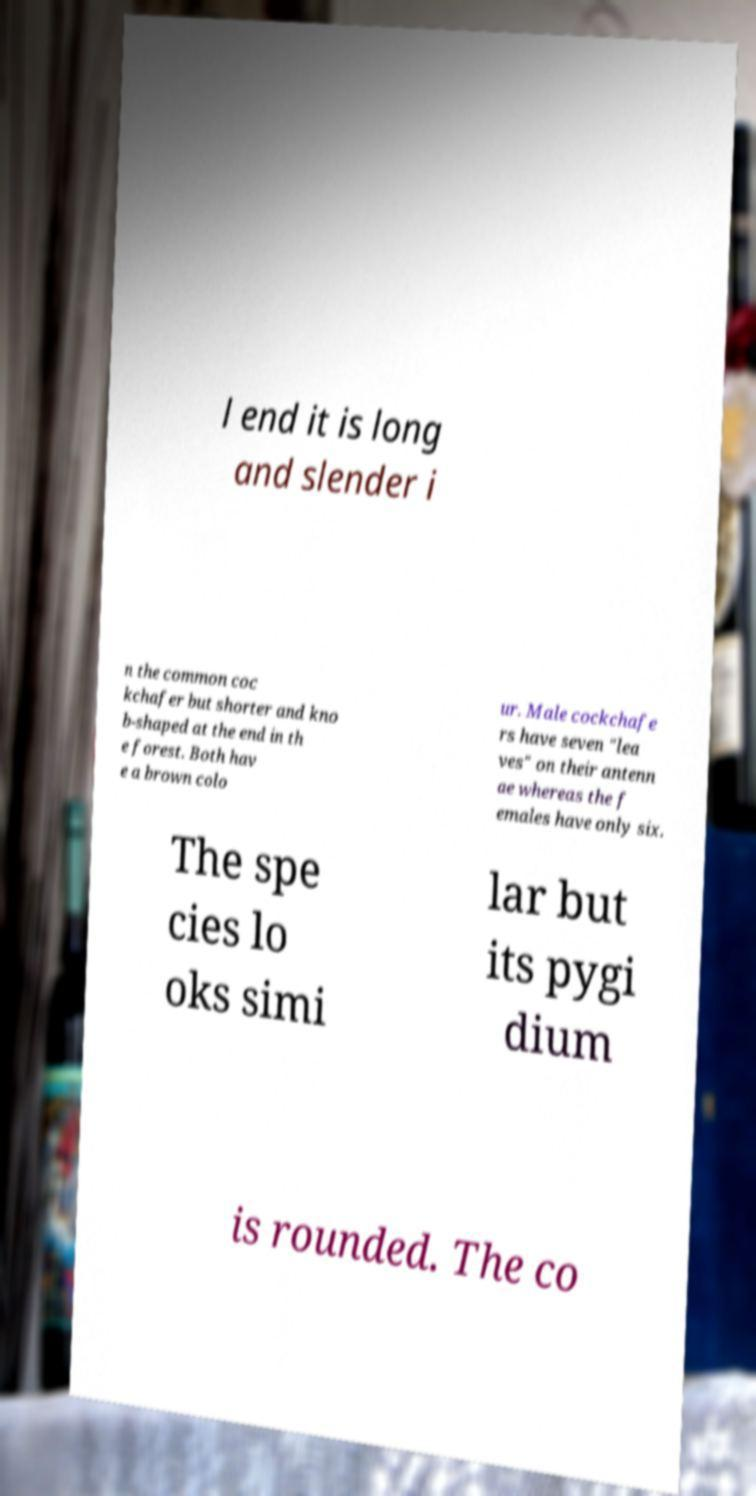What messages or text are displayed in this image? I need them in a readable, typed format. l end it is long and slender i n the common coc kchafer but shorter and kno b-shaped at the end in th e forest. Both hav e a brown colo ur. Male cockchafe rs have seven "lea ves" on their antenn ae whereas the f emales have only six. The spe cies lo oks simi lar but its pygi dium is rounded. The co 